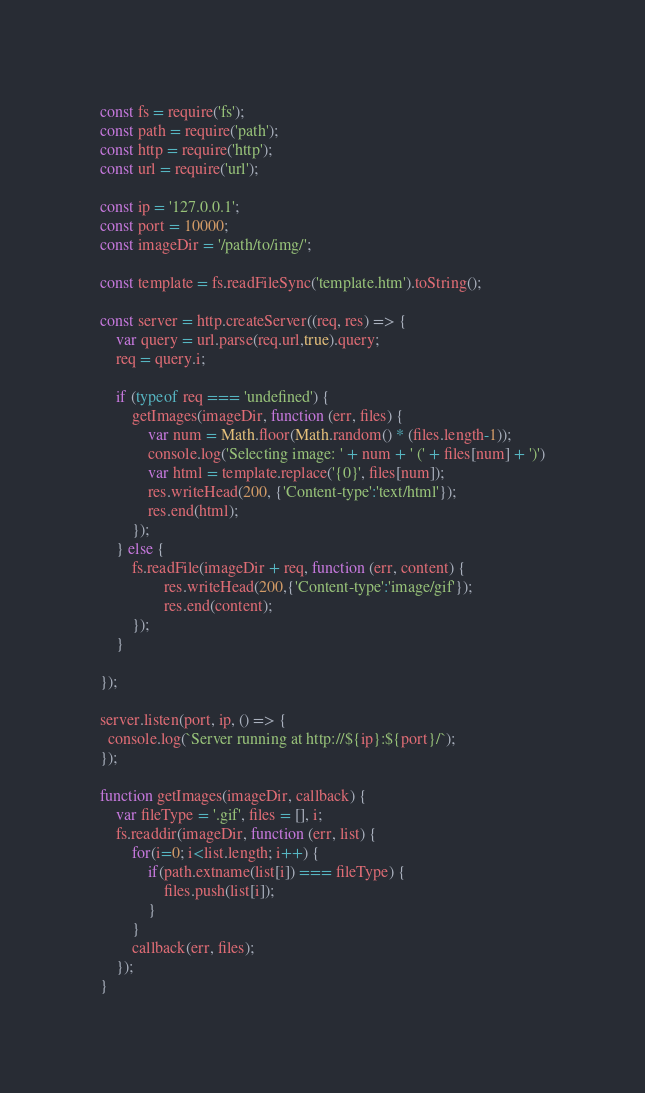Convert code to text. <code><loc_0><loc_0><loc_500><loc_500><_JavaScript_>const fs = require('fs');
const path = require('path');
const http = require('http');
const url = require('url');

const ip = '127.0.0.1';
const port = 10000;
const imageDir = '/path/to/img/';

const template = fs.readFileSync('template.htm').toString();

const server = http.createServer((req, res) => {
    var query = url.parse(req.url,true).query;
    req = query.i;

    if (typeof req === 'undefined') {
        getImages(imageDir, function (err, files) {
        	var num = Math.floor(Math.random() * (files.length-1));
        	console.log('Selecting image: ' + num + ' (' + files[num] + ')')
            var html = template.replace('{0}', files[num]);
            res.writeHead(200, {'Content-type':'text/html'});
            res.end(html);
        });
    } else {
        fs.readFile(imageDir + req, function (err, content) {
                res.writeHead(200,{'Content-type':'image/gif'});
                res.end(content);
        });
    }

});

server.listen(port, ip, () => {
  console.log(`Server running at http://${ip}:${port}/`);
});

function getImages(imageDir, callback) {
    var fileType = '.gif', files = [], i;
    fs.readdir(imageDir, function (err, list) {
        for(i=0; i<list.length; i++) {
            if(path.extname(list[i]) === fileType) {
                files.push(list[i]);
            }
        }
        callback(err, files);
    });
}
</code> 